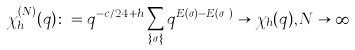Convert formula to latex. <formula><loc_0><loc_0><loc_500><loc_500>\chi _ { h } ^ { ( N ) } ( q ) \colon = q ^ { - c / 2 4 + h } \sum _ { \{ \sigma \} } q ^ { E ( \sigma ) - E ( \sigma _ { h } ) } \to \chi _ { h } ( q ) , N \to \infty</formula> 